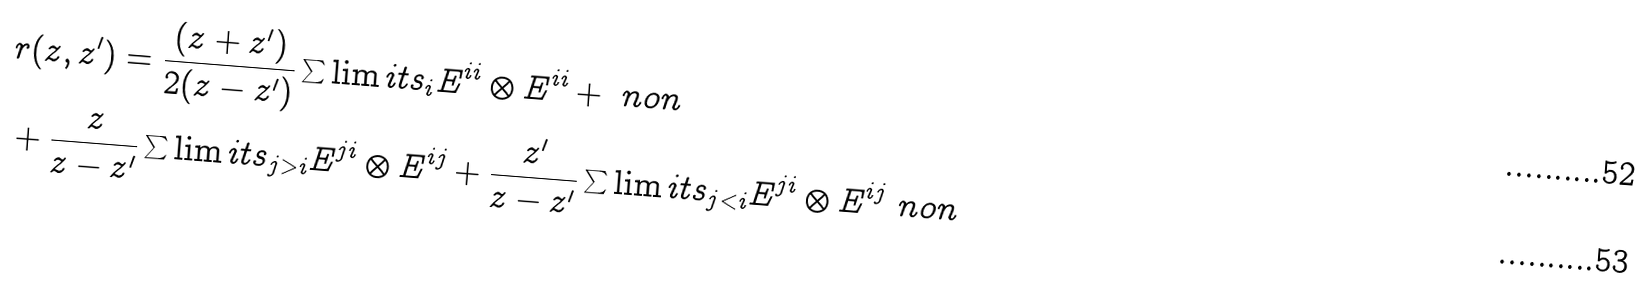Convert formula to latex. <formula><loc_0><loc_0><loc_500><loc_500>& r ( z , z ^ { \prime } ) = \frac { ( z + z ^ { \prime } ) } { 2 ( z - z ^ { \prime } ) } \sum \lim i t s _ { i } E ^ { i i } \otimes E ^ { i i } + \ n o n \\ & + \frac { z } { z - z ^ { \prime } } \sum \lim i t s _ { j > i } E ^ { j i } \otimes E ^ { i j } + \frac { z ^ { \prime } } { z - z ^ { \prime } } \sum \lim i t s _ { j < i } E ^ { j i } \otimes E ^ { i j } \ n o n</formula> 